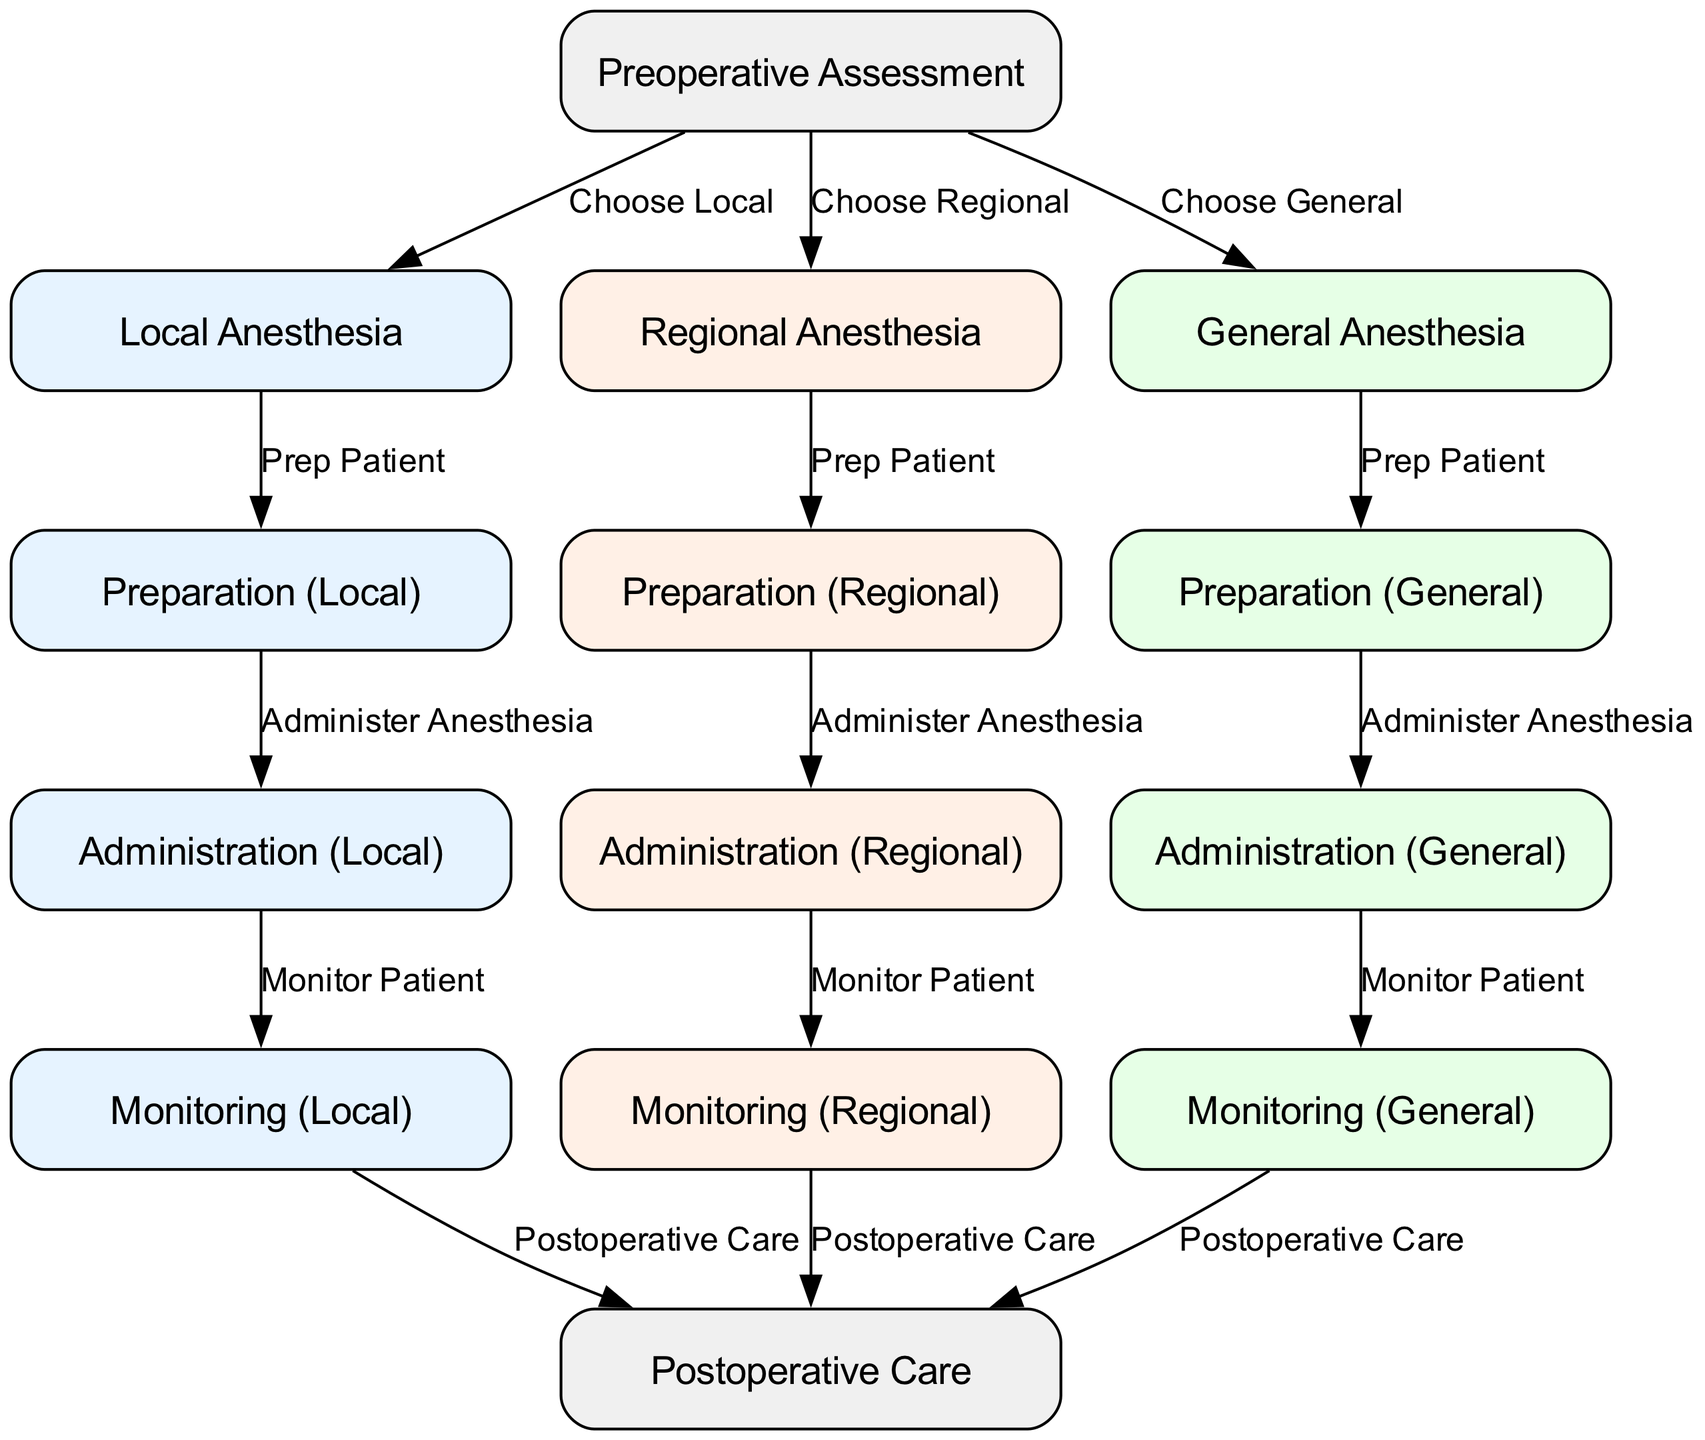What are the three main types of anesthesia? The diagram contains three main nodes labeled as "Local Anesthesia", "Regional Anesthesia", and "General Anesthesia", clearly indicating the three different types of anesthesia considered in surgical settings.
Answer: Local Anesthesia, Regional Anesthesia, General Anesthesia How many preparation stages are there? The diagram shows three specific preparation nodes: "Preparation (Local)", "Preparation (Regional)", and "Preparation (General)", representing the stages for each anesthesia type.
Answer: 3 What is the last step after monitoring general anesthesia? In the diagram, the flow directs from "Monitoring (General)" to "Postoperative Care", indicating that postoperative care is the final step after monitoring.
Answer: Postoperative Care Which anesthesia type requires the step "Prep Patient"? The edges connecting the "Preoperative Assessment" node to the anesthesia types indicate that all three—local, regional, and general anesthesia—require the "Prep Patient" step prior to their respective preparations.
Answer: All three Which type of anesthesia has the color representing local procedures? The diagram indicates that nodes related to "Local Anesthesia" are filled with a specific light blue color (#E6F3FF), distinguishing it from the other anesthesia types which have different colors.
Answer: Light Blue What should be monitored after the administration of regional anesthesia? Referring to the flow from "Administration (Regional)", it directs to "Monitoring (Regional)", indicating that this step is essential after administering regional anesthesia.
Answer: Monitoring (Regional) How many pairs of monitoring and postoperative care exist? The diagram presents three monitoring nodes—"Monitoring (Local)", "Monitoring (Regional)", and "Monitoring (General)"—each connected to "Postoperative Care", resulting in three pairs total.
Answer: 3 What is the relationship between "Administration (Local)" and "Monitoring (Local)"? The directed edge in the diagram indicates a sequential relationship where "Administration (Local)" must occur before "Monitoring (Local)", highlighting the workflow during local anesthesia.
Answer: Sequential Relationship What action follows preparation for general anesthesia? The diagram shows that after "Preparation (General)", the next step is "Administration (General)", establishing a logical flow indicating the subsequent action post-preparation.
Answer: Administration (General) 